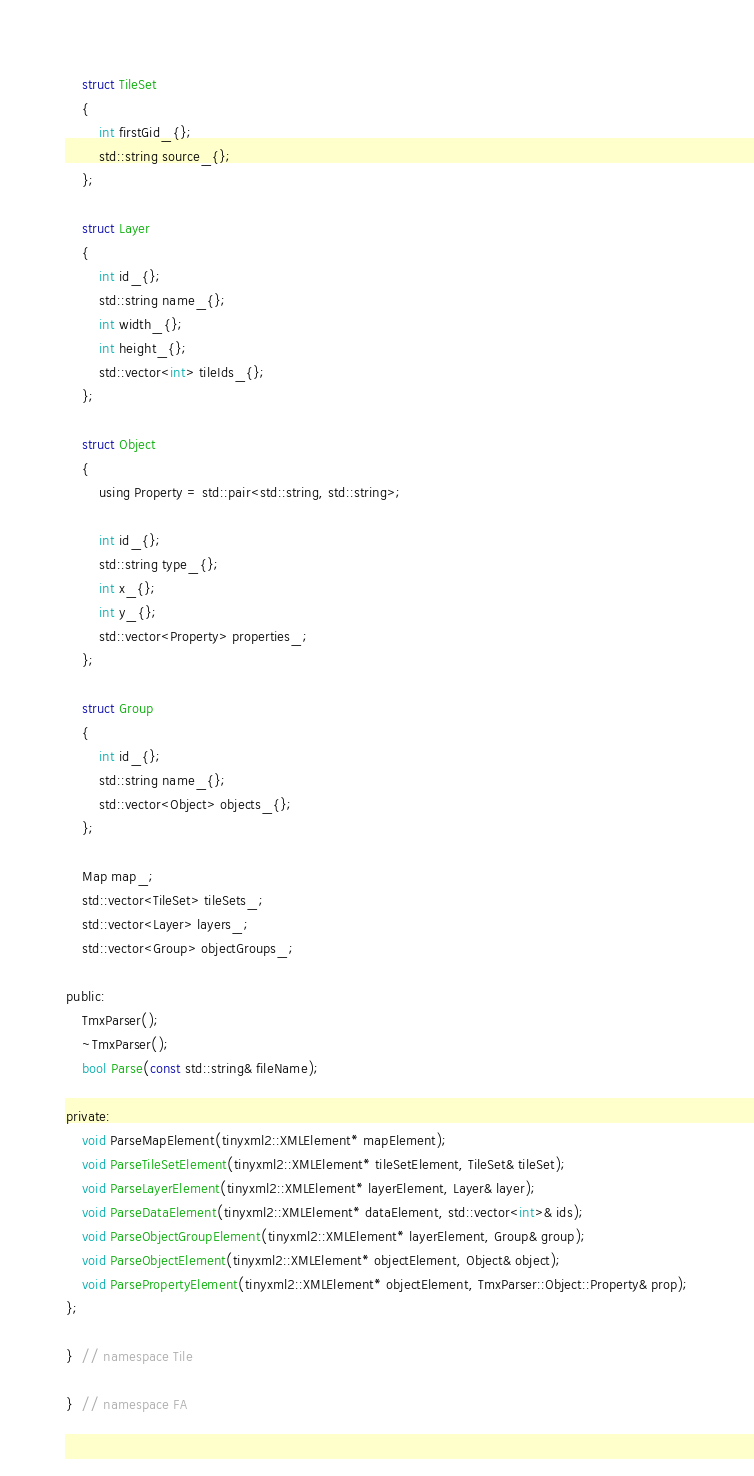<code> <loc_0><loc_0><loc_500><loc_500><_C_>
    struct TileSet
    {
        int firstGid_{};
        std::string source_{};
    };

    struct Layer
    {
        int id_{};
        std::string name_{};
        int width_{};
        int height_{};
        std::vector<int> tileIds_{};
    };

    struct Object
    {
        using Property = std::pair<std::string, std::string>;

        int id_{};
        std::string type_{};
        int x_{};
        int y_{};
        std::vector<Property> properties_;
    };

    struct Group
    {
        int id_{};
        std::string name_{};
        std::vector<Object> objects_{};
    };

    Map map_;
    std::vector<TileSet> tileSets_;
    std::vector<Layer> layers_;
    std::vector<Group> objectGroups_;

public:
    TmxParser();
    ~TmxParser();
    bool Parse(const std::string& fileName);

private:
    void ParseMapElement(tinyxml2::XMLElement* mapElement);
    void ParseTileSetElement(tinyxml2::XMLElement* tileSetElement, TileSet& tileSet);
    void ParseLayerElement(tinyxml2::XMLElement* layerElement, Layer& layer);
    void ParseDataElement(tinyxml2::XMLElement* dataElement, std::vector<int>& ids);
    void ParseObjectGroupElement(tinyxml2::XMLElement* layerElement, Group& group);
    void ParseObjectElement(tinyxml2::XMLElement* objectElement, Object& object);
    void ParsePropertyElement(tinyxml2::XMLElement* objectElement, TmxParser::Object::Property& prop);
};

}  // namespace Tile

}  // namespace FA
</code> 